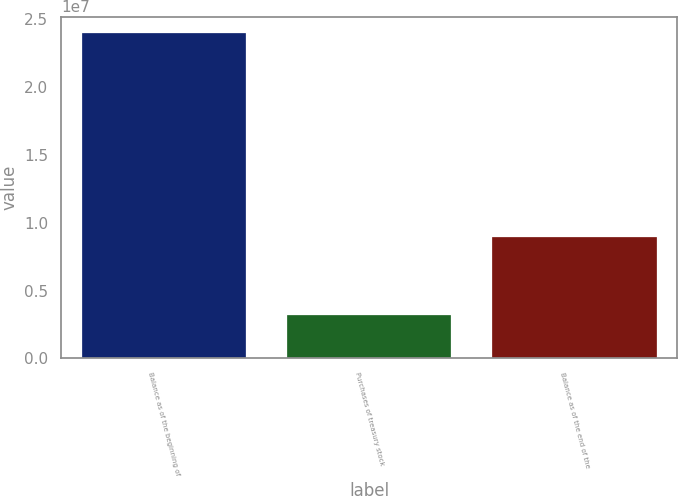<chart> <loc_0><loc_0><loc_500><loc_500><bar_chart><fcel>Balance as of the beginning of<fcel>Purchases of treasury stock<fcel>Balance as of the end of the<nl><fcel>2.39868e+07<fcel>3.1922e+06<fcel>8.92814e+06<nl></chart> 